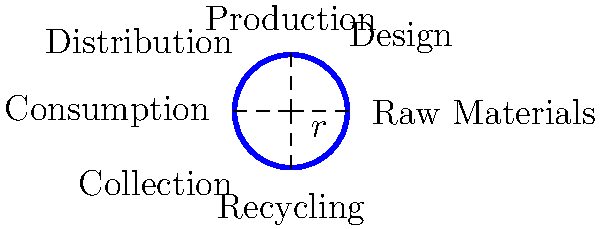In a circular economy model, the perimeter of the circle represents the continuous flow of resources. If the radius of this circle is $r = 2$ units, calculate the economic efficiency factor $E$, defined as the ratio of the circle's perimeter to its diameter. How might this factor relate to the potential for resource conservation in a circular economy? To solve this problem, we'll follow these steps:

1) First, recall the formula for the circumference (perimeter) of a circle:
   $C = 2\pi r$

2) Given that $r = 2$ units, we can calculate the circumference:
   $C = 2\pi(2) = 4\pi$ units

3) The diameter of the circle is twice the radius:
   $d = 2r = 2(2) = 4$ units

4) The economic efficiency factor $E$ is defined as the ratio of the perimeter to the diameter:
   $E = \frac{\text{perimeter}}{\text{diameter}} = \frac{C}{d} = \frac{4\pi}{4} = \pi$

5) Therefore, $E = \pi \approx 3.14159$

This factor represents the idea that in a circular economy, resources complete a full cycle (represented by the circumference) for every linear distance (represented by the diameter) they travel through the economic system. A higher ratio suggests greater resource efficiency and conservation potential.

In this case, the ratio being $\pi$ implies that for every unit of linear resource flow, we get $\pi$ units of circular resource use, representing a significant potential for resource conservation compared to a linear economy.
Answer: $E = \pi \approx 3.14159$ 